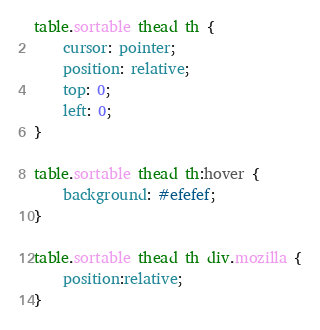<code> <loc_0><loc_0><loc_500><loc_500><_CSS_>table.sortable thead th {
    cursor: pointer;
    position: relative;
    top: 0;
    left: 0;
}

table.sortable thead th:hover {
    background: #efefef;
}

table.sortable thead th div.mozilla {
    position:relative;
}</code> 